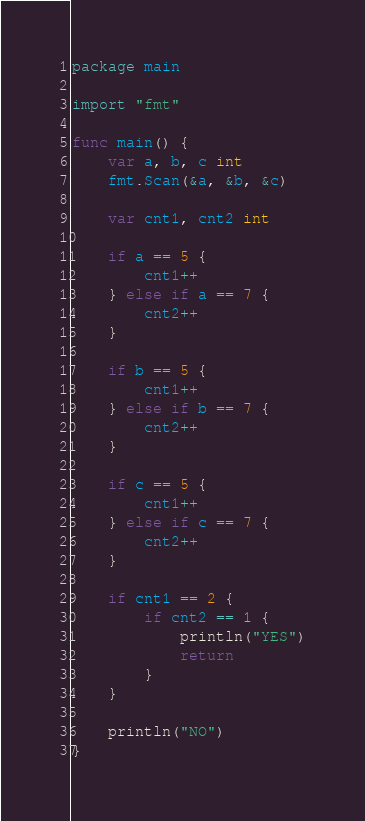<code> <loc_0><loc_0><loc_500><loc_500><_Go_>package main

import "fmt"

func main() {
	var a, b, c int
	fmt.Scan(&a, &b, &c)

	var cnt1, cnt2 int

	if a == 5 {
		cnt1++
	} else if a == 7 {
		cnt2++
	}

	if b == 5 {
		cnt1++
	} else if b == 7 {
		cnt2++
	}

	if c == 5 {
		cnt1++
	} else if c == 7 {
		cnt2++
	}

	if cnt1 == 2 {
		if cnt2 == 1 {
			println("YES")
			return
		}
	}

	println("NO")
}
</code> 